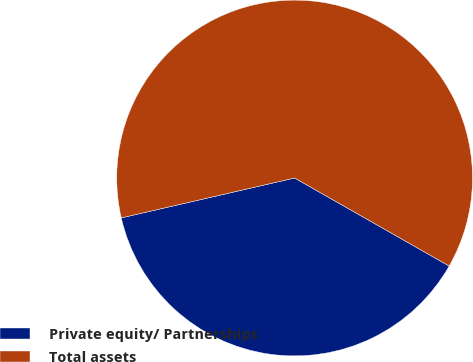<chart> <loc_0><loc_0><loc_500><loc_500><pie_chart><fcel>Private equity/ Partnerships<fcel>Total assets<nl><fcel>38.16%<fcel>61.84%<nl></chart> 